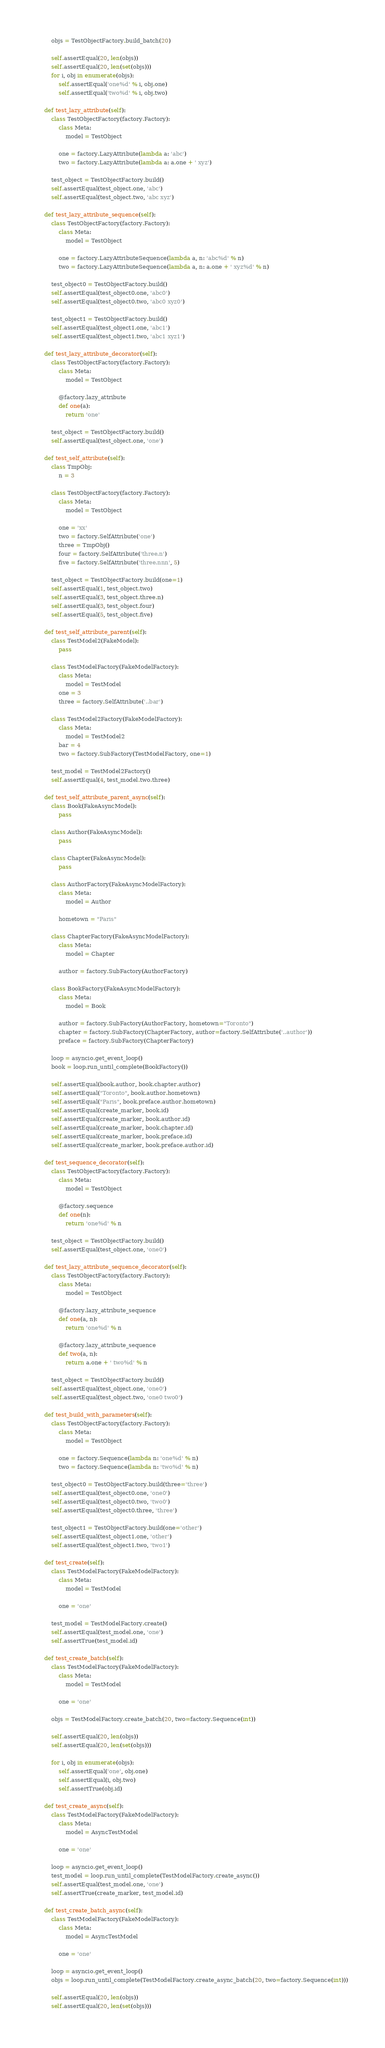<code> <loc_0><loc_0><loc_500><loc_500><_Python_>        objs = TestObjectFactory.build_batch(20)

        self.assertEqual(20, len(objs))
        self.assertEqual(20, len(set(objs)))
        for i, obj in enumerate(objs):
            self.assertEqual('one%d' % i, obj.one)
            self.assertEqual('two%d' % i, obj.two)

    def test_lazy_attribute(self):
        class TestObjectFactory(factory.Factory):
            class Meta:
                model = TestObject

            one = factory.LazyAttribute(lambda a: 'abc')
            two = factory.LazyAttribute(lambda a: a.one + ' xyz')

        test_object = TestObjectFactory.build()
        self.assertEqual(test_object.one, 'abc')
        self.assertEqual(test_object.two, 'abc xyz')

    def test_lazy_attribute_sequence(self):
        class TestObjectFactory(factory.Factory):
            class Meta:
                model = TestObject

            one = factory.LazyAttributeSequence(lambda a, n: 'abc%d' % n)
            two = factory.LazyAttributeSequence(lambda a, n: a.one + ' xyz%d' % n)

        test_object0 = TestObjectFactory.build()
        self.assertEqual(test_object0.one, 'abc0')
        self.assertEqual(test_object0.two, 'abc0 xyz0')

        test_object1 = TestObjectFactory.build()
        self.assertEqual(test_object1.one, 'abc1')
        self.assertEqual(test_object1.two, 'abc1 xyz1')

    def test_lazy_attribute_decorator(self):
        class TestObjectFactory(factory.Factory):
            class Meta:
                model = TestObject

            @factory.lazy_attribute
            def one(a):
                return 'one'

        test_object = TestObjectFactory.build()
        self.assertEqual(test_object.one, 'one')

    def test_self_attribute(self):
        class TmpObj:
            n = 3

        class TestObjectFactory(factory.Factory):
            class Meta:
                model = TestObject

            one = 'xx'
            two = factory.SelfAttribute('one')
            three = TmpObj()
            four = factory.SelfAttribute('three.n')
            five = factory.SelfAttribute('three.nnn', 5)

        test_object = TestObjectFactory.build(one=1)
        self.assertEqual(1, test_object.two)
        self.assertEqual(3, test_object.three.n)
        self.assertEqual(3, test_object.four)
        self.assertEqual(5, test_object.five)

    def test_self_attribute_parent(self):
        class TestModel2(FakeModel):
            pass

        class TestModelFactory(FakeModelFactory):
            class Meta:
                model = TestModel
            one = 3
            three = factory.SelfAttribute('..bar')

        class TestModel2Factory(FakeModelFactory):
            class Meta:
                model = TestModel2
            bar = 4
            two = factory.SubFactory(TestModelFactory, one=1)

        test_model = TestModel2Factory()
        self.assertEqual(4, test_model.two.three)

    def test_self_attribute_parent_async(self):
        class Book(FakeAsyncModel):
            pass

        class Author(FakeAsyncModel):
            pass

        class Chapter(FakeAsyncModel):
            pass

        class AuthorFactory(FakeAsyncModelFactory):
            class Meta:
                model = Author

            hometown = "Paris"

        class ChapterFactory(FakeAsyncModelFactory):
            class Meta:
                model = Chapter

            author = factory.SubFactory(AuthorFactory)

        class BookFactory(FakeAsyncModelFactory):
            class Meta:
                model = Book

            author = factory.SubFactory(AuthorFactory, hometown="Toronto")
            chapter = factory.SubFactory(ChapterFactory, author=factory.SelfAttribute('..author'))
            preface = factory.SubFactory(ChapterFactory)

        loop = asyncio.get_event_loop()
        book = loop.run_until_complete(BookFactory())

        self.assertEqual(book.author, book.chapter.author)
        self.assertEqual("Toronto", book.author.hometown)
        self.assertEqual("Paris", book.preface.author.hometown)
        self.assertEqual(create_marker, book.id)
        self.assertEqual(create_marker, book.author.id)
        self.assertEqual(create_marker, book.chapter.id)
        self.assertEqual(create_marker, book.preface.id)
        self.assertEqual(create_marker, book.preface.author.id)

    def test_sequence_decorator(self):
        class TestObjectFactory(factory.Factory):
            class Meta:
                model = TestObject

            @factory.sequence
            def one(n):
                return 'one%d' % n

        test_object = TestObjectFactory.build()
        self.assertEqual(test_object.one, 'one0')

    def test_lazy_attribute_sequence_decorator(self):
        class TestObjectFactory(factory.Factory):
            class Meta:
                model = TestObject

            @factory.lazy_attribute_sequence
            def one(a, n):
                return 'one%d' % n

            @factory.lazy_attribute_sequence
            def two(a, n):
                return a.one + ' two%d' % n

        test_object = TestObjectFactory.build()
        self.assertEqual(test_object.one, 'one0')
        self.assertEqual(test_object.two, 'one0 two0')

    def test_build_with_parameters(self):
        class TestObjectFactory(factory.Factory):
            class Meta:
                model = TestObject

            one = factory.Sequence(lambda n: 'one%d' % n)
            two = factory.Sequence(lambda n: 'two%d' % n)

        test_object0 = TestObjectFactory.build(three='three')
        self.assertEqual(test_object0.one, 'one0')
        self.assertEqual(test_object0.two, 'two0')
        self.assertEqual(test_object0.three, 'three')

        test_object1 = TestObjectFactory.build(one='other')
        self.assertEqual(test_object1.one, 'other')
        self.assertEqual(test_object1.two, 'two1')

    def test_create(self):
        class TestModelFactory(FakeModelFactory):
            class Meta:
                model = TestModel

            one = 'one'

        test_model = TestModelFactory.create()
        self.assertEqual(test_model.one, 'one')
        self.assertTrue(test_model.id)

    def test_create_batch(self):
        class TestModelFactory(FakeModelFactory):
            class Meta:
                model = TestModel

            one = 'one'

        objs = TestModelFactory.create_batch(20, two=factory.Sequence(int))

        self.assertEqual(20, len(objs))
        self.assertEqual(20, len(set(objs)))

        for i, obj in enumerate(objs):
            self.assertEqual('one', obj.one)
            self.assertEqual(i, obj.two)
            self.assertTrue(obj.id)

    def test_create_async(self):
        class TestModelFactory(FakeModelFactory):
            class Meta:
                model = AsyncTestModel

            one = 'one'

        loop = asyncio.get_event_loop()
        test_model = loop.run_until_complete(TestModelFactory.create_async())
        self.assertEqual(test_model.one, 'one')
        self.assertTrue(create_marker, test_model.id)

    def test_create_batch_async(self):
        class TestModelFactory(FakeModelFactory):
            class Meta:
                model = AsyncTestModel

            one = 'one'

        loop = asyncio.get_event_loop()
        objs = loop.run_until_complete(TestModelFactory.create_async_batch(20, two=factory.Sequence(int)))

        self.assertEqual(20, len(objs))
        self.assertEqual(20, len(set(objs)))
</code> 